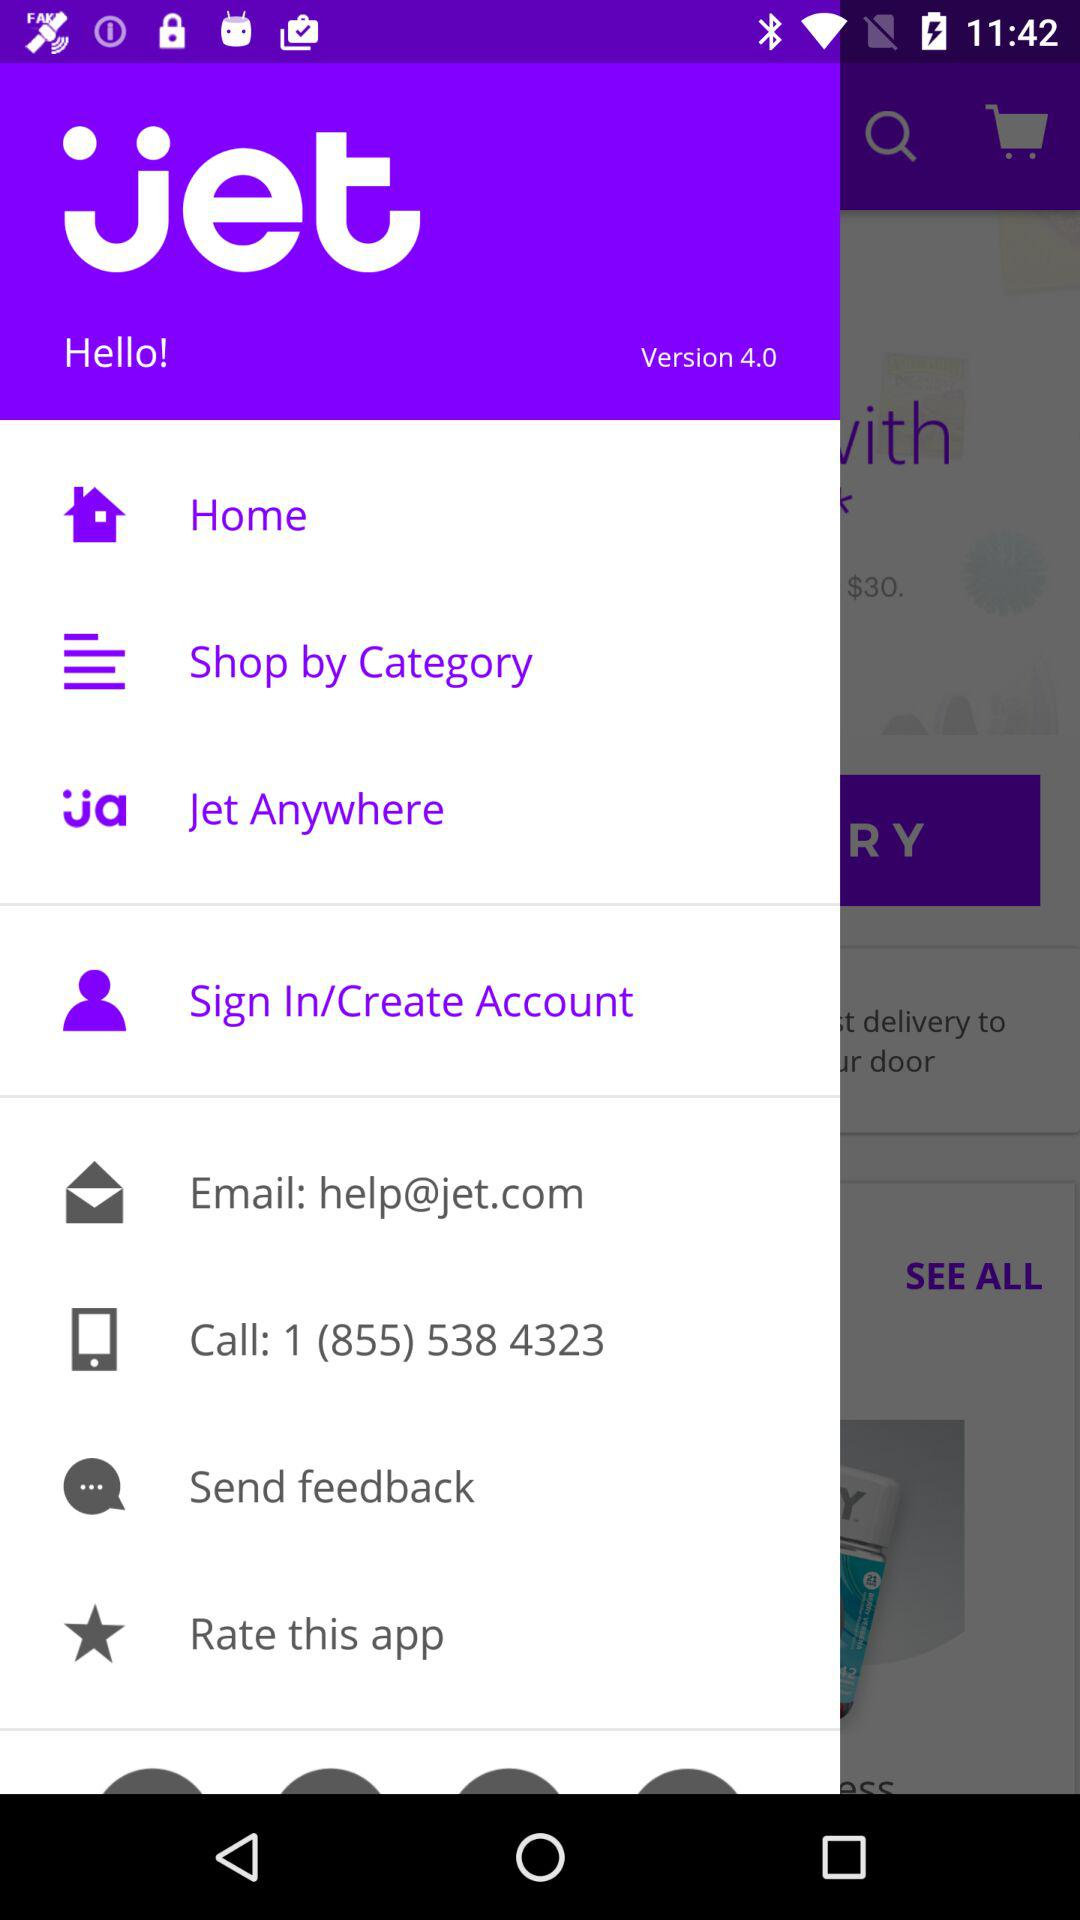What is the version of the application? The version of the application is 4.0. 